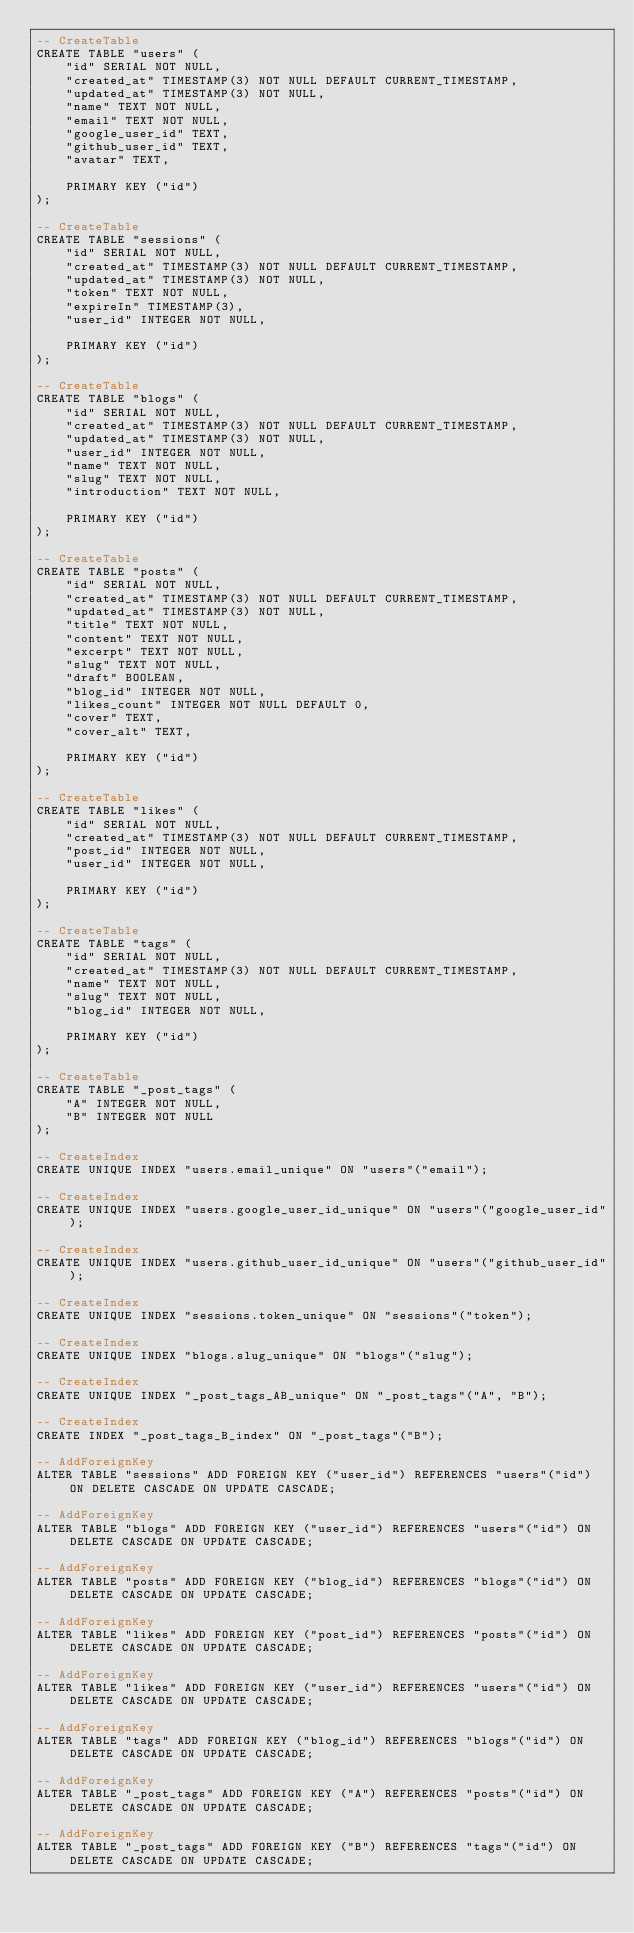Convert code to text. <code><loc_0><loc_0><loc_500><loc_500><_SQL_>-- CreateTable
CREATE TABLE "users" (
    "id" SERIAL NOT NULL,
    "created_at" TIMESTAMP(3) NOT NULL DEFAULT CURRENT_TIMESTAMP,
    "updated_at" TIMESTAMP(3) NOT NULL,
    "name" TEXT NOT NULL,
    "email" TEXT NOT NULL,
    "google_user_id" TEXT,
    "github_user_id" TEXT,
    "avatar" TEXT,

    PRIMARY KEY ("id")
);

-- CreateTable
CREATE TABLE "sessions" (
    "id" SERIAL NOT NULL,
    "created_at" TIMESTAMP(3) NOT NULL DEFAULT CURRENT_TIMESTAMP,
    "updated_at" TIMESTAMP(3) NOT NULL,
    "token" TEXT NOT NULL,
    "expireIn" TIMESTAMP(3),
    "user_id" INTEGER NOT NULL,

    PRIMARY KEY ("id")
);

-- CreateTable
CREATE TABLE "blogs" (
    "id" SERIAL NOT NULL,
    "created_at" TIMESTAMP(3) NOT NULL DEFAULT CURRENT_TIMESTAMP,
    "updated_at" TIMESTAMP(3) NOT NULL,
    "user_id" INTEGER NOT NULL,
    "name" TEXT NOT NULL,
    "slug" TEXT NOT NULL,
    "introduction" TEXT NOT NULL,

    PRIMARY KEY ("id")
);

-- CreateTable
CREATE TABLE "posts" (
    "id" SERIAL NOT NULL,
    "created_at" TIMESTAMP(3) NOT NULL DEFAULT CURRENT_TIMESTAMP,
    "updated_at" TIMESTAMP(3) NOT NULL,
    "title" TEXT NOT NULL,
    "content" TEXT NOT NULL,
    "excerpt" TEXT NOT NULL,
    "slug" TEXT NOT NULL,
    "draft" BOOLEAN,
    "blog_id" INTEGER NOT NULL,
    "likes_count" INTEGER NOT NULL DEFAULT 0,
    "cover" TEXT,
    "cover_alt" TEXT,

    PRIMARY KEY ("id")
);

-- CreateTable
CREATE TABLE "likes" (
    "id" SERIAL NOT NULL,
    "created_at" TIMESTAMP(3) NOT NULL DEFAULT CURRENT_TIMESTAMP,
    "post_id" INTEGER NOT NULL,
    "user_id" INTEGER NOT NULL,

    PRIMARY KEY ("id")
);

-- CreateTable
CREATE TABLE "tags" (
    "id" SERIAL NOT NULL,
    "created_at" TIMESTAMP(3) NOT NULL DEFAULT CURRENT_TIMESTAMP,
    "name" TEXT NOT NULL,
    "slug" TEXT NOT NULL,
    "blog_id" INTEGER NOT NULL,

    PRIMARY KEY ("id")
);

-- CreateTable
CREATE TABLE "_post_tags" (
    "A" INTEGER NOT NULL,
    "B" INTEGER NOT NULL
);

-- CreateIndex
CREATE UNIQUE INDEX "users.email_unique" ON "users"("email");

-- CreateIndex
CREATE UNIQUE INDEX "users.google_user_id_unique" ON "users"("google_user_id");

-- CreateIndex
CREATE UNIQUE INDEX "users.github_user_id_unique" ON "users"("github_user_id");

-- CreateIndex
CREATE UNIQUE INDEX "sessions.token_unique" ON "sessions"("token");

-- CreateIndex
CREATE UNIQUE INDEX "blogs.slug_unique" ON "blogs"("slug");

-- CreateIndex
CREATE UNIQUE INDEX "_post_tags_AB_unique" ON "_post_tags"("A", "B");

-- CreateIndex
CREATE INDEX "_post_tags_B_index" ON "_post_tags"("B");

-- AddForeignKey
ALTER TABLE "sessions" ADD FOREIGN KEY ("user_id") REFERENCES "users"("id") ON DELETE CASCADE ON UPDATE CASCADE;

-- AddForeignKey
ALTER TABLE "blogs" ADD FOREIGN KEY ("user_id") REFERENCES "users"("id") ON DELETE CASCADE ON UPDATE CASCADE;

-- AddForeignKey
ALTER TABLE "posts" ADD FOREIGN KEY ("blog_id") REFERENCES "blogs"("id") ON DELETE CASCADE ON UPDATE CASCADE;

-- AddForeignKey
ALTER TABLE "likes" ADD FOREIGN KEY ("post_id") REFERENCES "posts"("id") ON DELETE CASCADE ON UPDATE CASCADE;

-- AddForeignKey
ALTER TABLE "likes" ADD FOREIGN KEY ("user_id") REFERENCES "users"("id") ON DELETE CASCADE ON UPDATE CASCADE;

-- AddForeignKey
ALTER TABLE "tags" ADD FOREIGN KEY ("blog_id") REFERENCES "blogs"("id") ON DELETE CASCADE ON UPDATE CASCADE;

-- AddForeignKey
ALTER TABLE "_post_tags" ADD FOREIGN KEY ("A") REFERENCES "posts"("id") ON DELETE CASCADE ON UPDATE CASCADE;

-- AddForeignKey
ALTER TABLE "_post_tags" ADD FOREIGN KEY ("B") REFERENCES "tags"("id") ON DELETE CASCADE ON UPDATE CASCADE;
</code> 